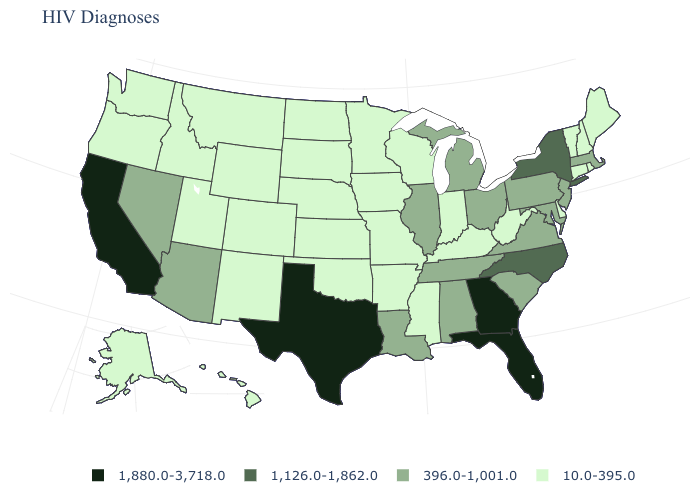What is the value of New York?
Short answer required. 1,126.0-1,862.0. Name the states that have a value in the range 1,880.0-3,718.0?
Short answer required. California, Florida, Georgia, Texas. Which states have the lowest value in the USA?
Quick response, please. Alaska, Arkansas, Colorado, Connecticut, Delaware, Hawaii, Idaho, Indiana, Iowa, Kansas, Kentucky, Maine, Minnesota, Mississippi, Missouri, Montana, Nebraska, New Hampshire, New Mexico, North Dakota, Oklahoma, Oregon, Rhode Island, South Dakota, Utah, Vermont, Washington, West Virginia, Wisconsin, Wyoming. Does the first symbol in the legend represent the smallest category?
Answer briefly. No. What is the value of West Virginia?
Be succinct. 10.0-395.0. Does Hawaii have the highest value in the USA?
Write a very short answer. No. What is the highest value in the USA?
Short answer required. 1,880.0-3,718.0. Which states hav the highest value in the West?
Give a very brief answer. California. Among the states that border Rhode Island , does Massachusetts have the highest value?
Be succinct. Yes. What is the value of Michigan?
Give a very brief answer. 396.0-1,001.0. Among the states that border Rhode Island , which have the highest value?
Write a very short answer. Massachusetts. Name the states that have a value in the range 1,880.0-3,718.0?
Short answer required. California, Florida, Georgia, Texas. Name the states that have a value in the range 1,880.0-3,718.0?
Short answer required. California, Florida, Georgia, Texas. Name the states that have a value in the range 396.0-1,001.0?
Answer briefly. Alabama, Arizona, Illinois, Louisiana, Maryland, Massachusetts, Michigan, Nevada, New Jersey, Ohio, Pennsylvania, South Carolina, Tennessee, Virginia. Name the states that have a value in the range 1,880.0-3,718.0?
Concise answer only. California, Florida, Georgia, Texas. 